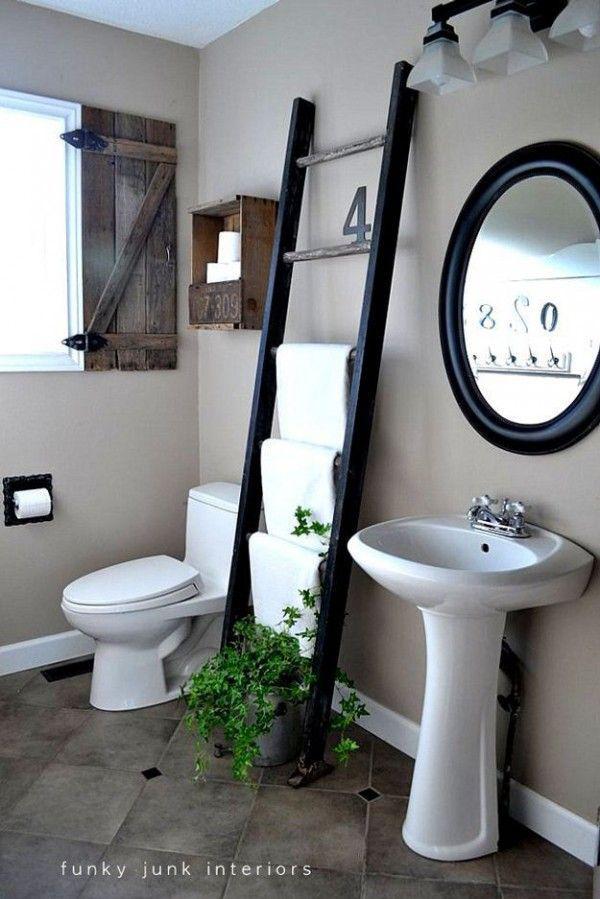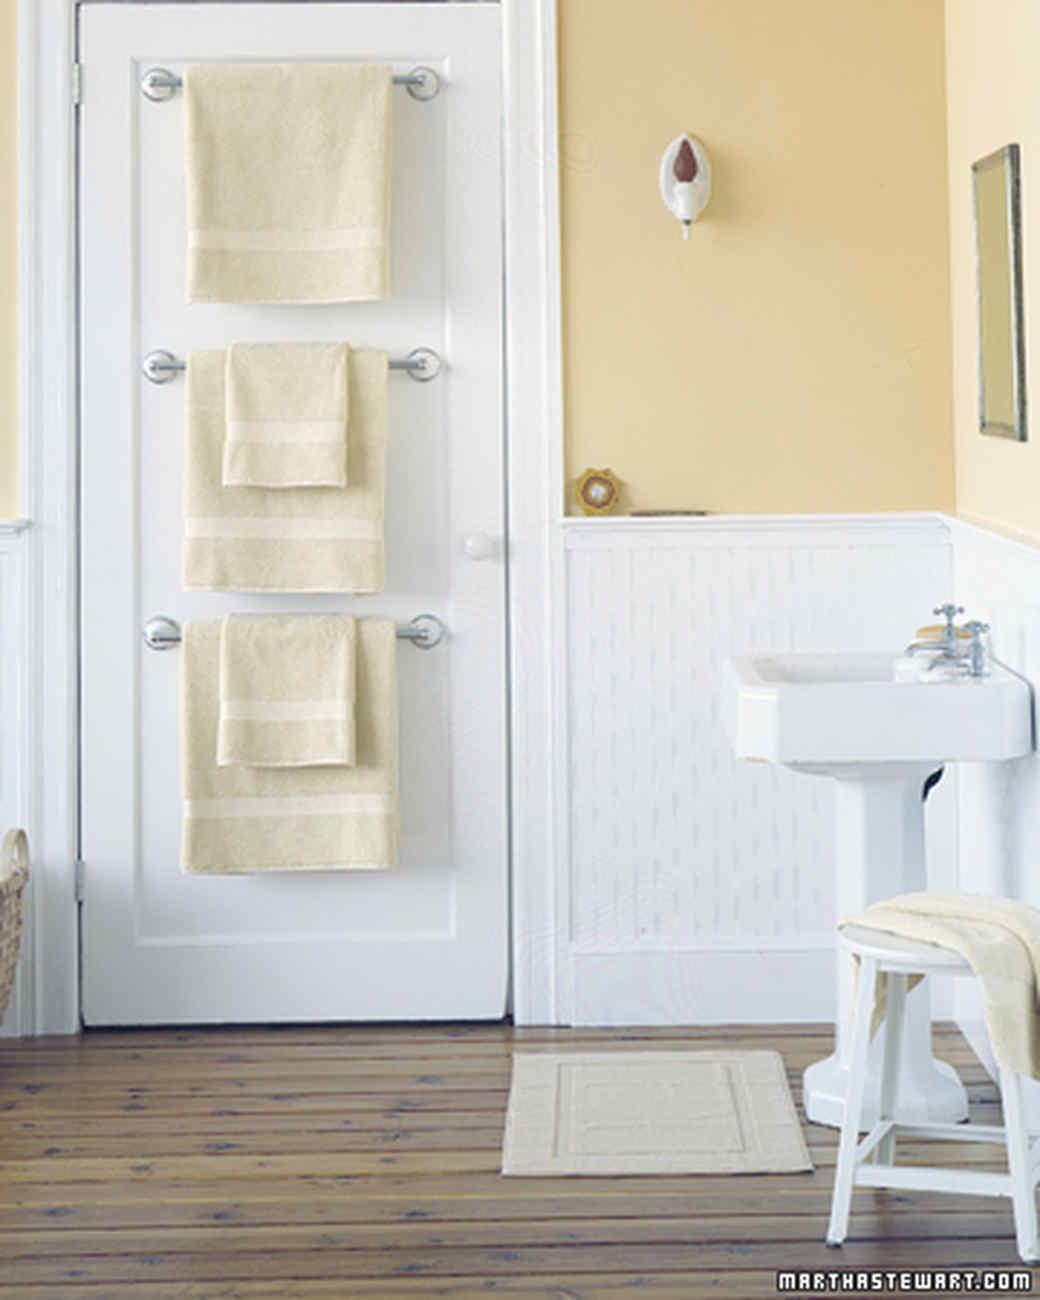The first image is the image on the left, the second image is the image on the right. Analyze the images presented: Is the assertion "There is a toilet in the image on the left" valid? Answer yes or no. Yes. 